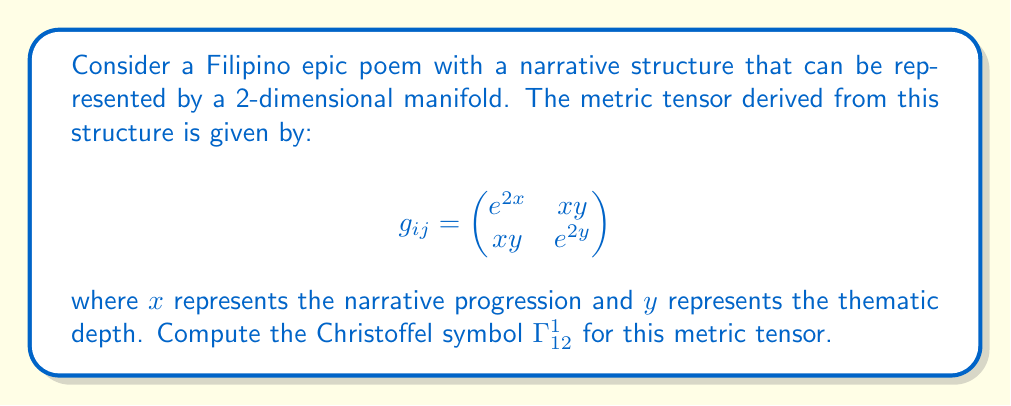Teach me how to tackle this problem. To compute the Christoffel symbol $\Gamma^1_{12}$, we'll use the formula:

$$\Gamma^k_{ij} = \frac{1}{2}g^{km}\left(\frac{\partial g_{mj}}{\partial x^i} + \frac{\partial g_{mi}}{\partial x^j} - \frac{\partial g_{ij}}{\partial x^m}\right)$$

Steps:
1) First, we need to find the inverse metric tensor $g^{ij}$:
   $$g^{ij} = \frac{1}{\det(g_{ij})}\begin{pmatrix}
   e^{2y} & -xy \\
   -xy & e^{2x}
   \end{pmatrix}$$
   where $\det(g_{ij}) = e^{2x+2y} - x^2y^2$

2) For $\Gamma^1_{12}$, we need $g^{11}$:
   $$g^{11} = \frac{e^{2y}}{e^{2x+2y} - x^2y^2}$$

3) Now, we calculate the partial derivatives:
   $$\frac{\partial g_{12}}{\partial x^1} = \frac{\partial (xy)}{\partial x} = y$$
   $$\frac{\partial g_{11}}{\partial x^2} = \frac{\partial (e^{2x})}{\partial y} = 0$$
   $$\frac{\partial g_{12}}{\partial x^1} = \frac{\partial (xy)}{\partial x} = y$$

4) Substituting into the formula:
   $$\Gamma^1_{12} = \frac{1}{2}g^{11}\left(\frac{\partial g_{12}}{\partial x^1} + \frac{\partial g_{11}}{\partial x^2} - \frac{\partial g_{12}}{\partial x^1}\right)$$
   $$= \frac{1}{2}\frac{e^{2y}}{e^{2x+2y} - x^2y^2}(y + 0 - y) = 0$$

Therefore, the Christoffel symbol $\Gamma^1_{12}$ is zero for this metric tensor.
Answer: $\Gamma^1_{12} = 0$ 